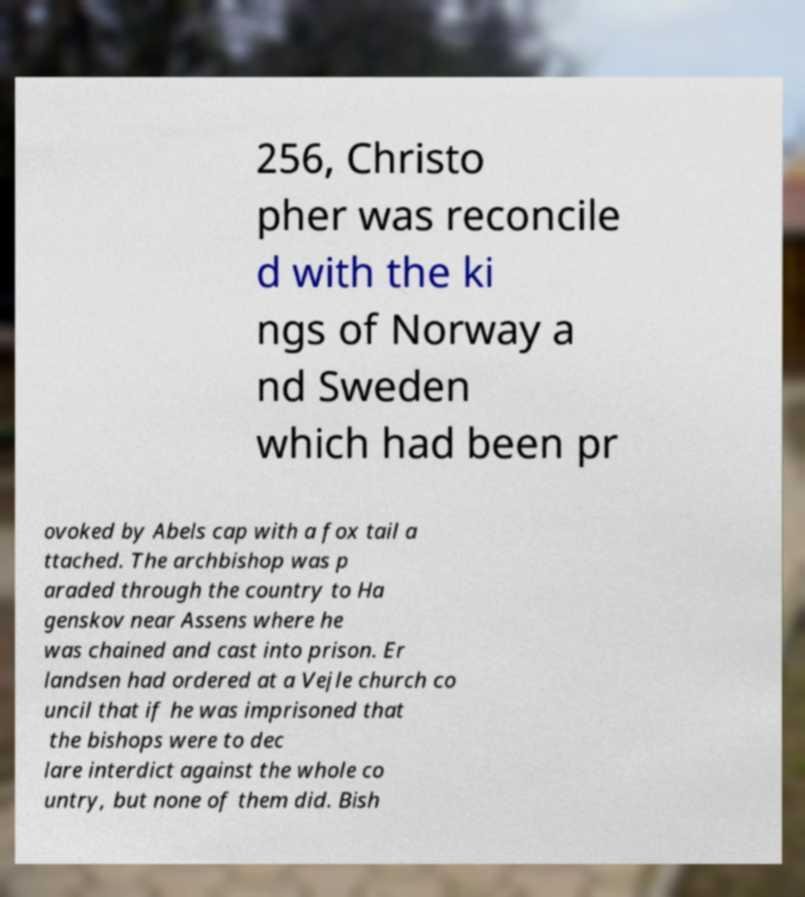What messages or text are displayed in this image? I need them in a readable, typed format. 256, Christo pher was reconcile d with the ki ngs of Norway a nd Sweden which had been pr ovoked by Abels cap with a fox tail a ttached. The archbishop was p araded through the country to Ha genskov near Assens where he was chained and cast into prison. Er landsen had ordered at a Vejle church co uncil that if he was imprisoned that the bishops were to dec lare interdict against the whole co untry, but none of them did. Bish 